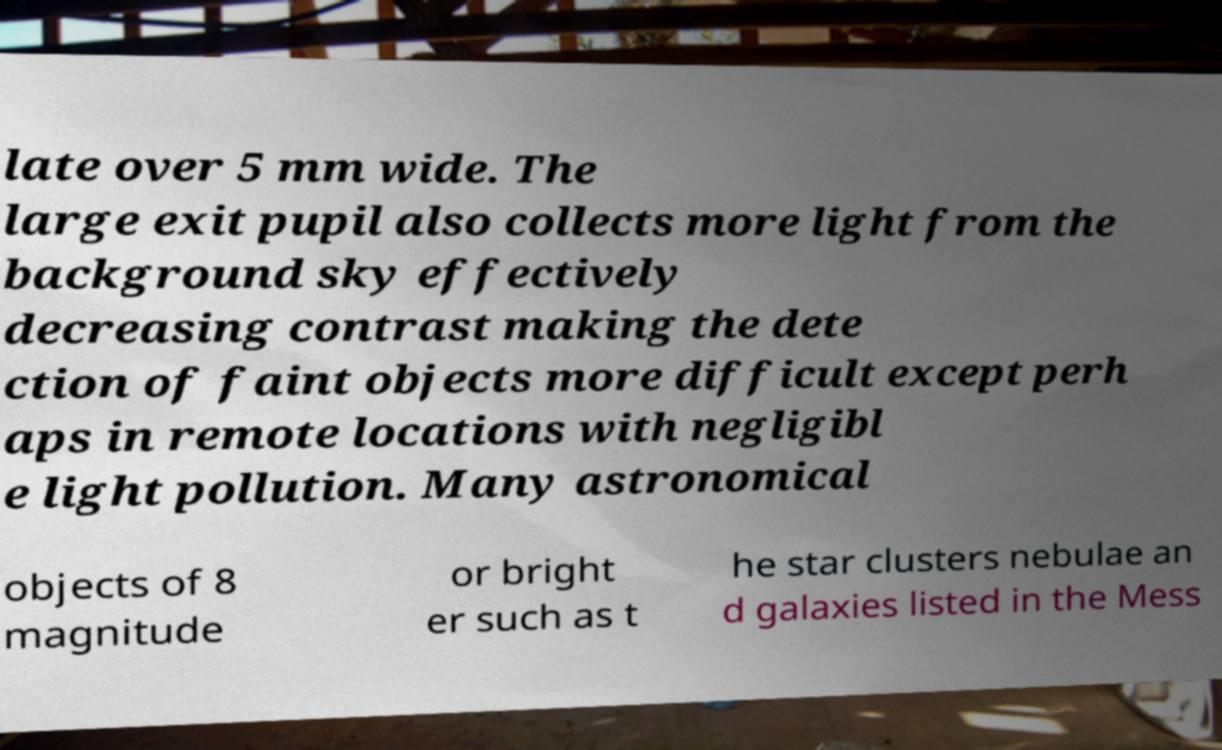Could you extract and type out the text from this image? late over 5 mm wide. The large exit pupil also collects more light from the background sky effectively decreasing contrast making the dete ction of faint objects more difficult except perh aps in remote locations with negligibl e light pollution. Many astronomical objects of 8 magnitude or bright er such as t he star clusters nebulae an d galaxies listed in the Mess 